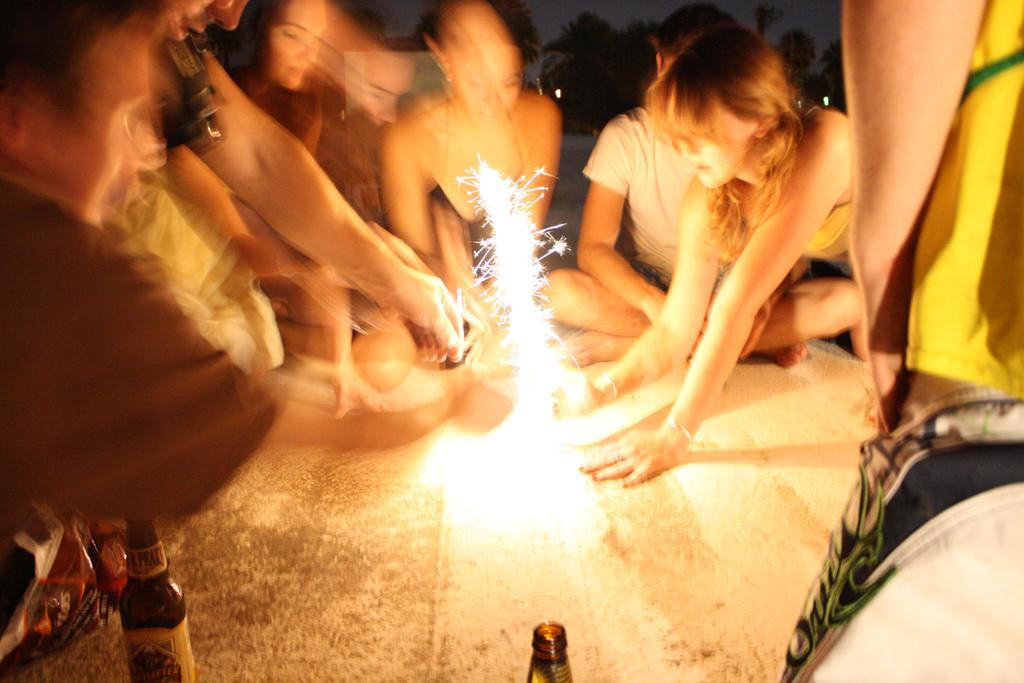Can you describe this image briefly? In this picture we can observe some people sitting around the fire. We can observe some bottles on the floor. There are men and women in this picture. In the background we can observe some trees. Some part of the picture was blurred. 